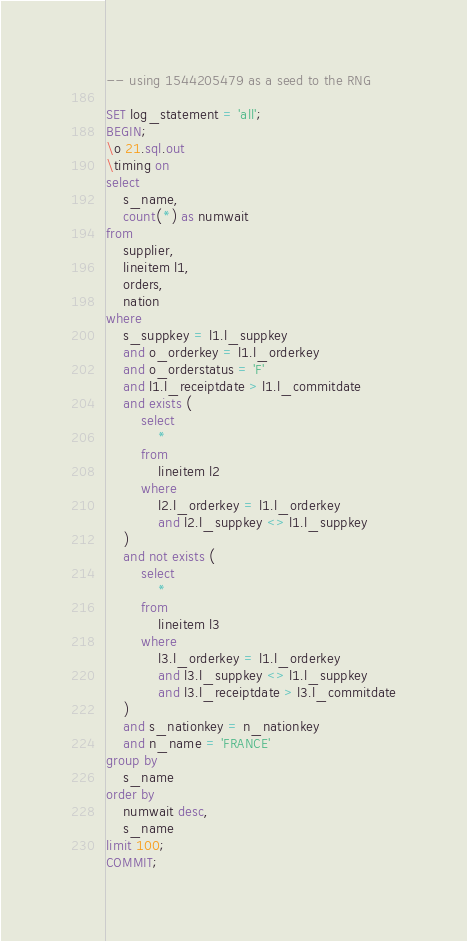<code> <loc_0><loc_0><loc_500><loc_500><_SQL_>-- using 1544205479 as a seed to the RNG

SET log_statement = 'all';
BEGIN;
\o 21.sql.out
\timing on
select
	s_name,
	count(*) as numwait
from
	supplier,
	lineitem l1,
	orders,
	nation
where
	s_suppkey = l1.l_suppkey
	and o_orderkey = l1.l_orderkey
	and o_orderstatus = 'F'
	and l1.l_receiptdate > l1.l_commitdate
	and exists (
		select
			*
		from
			lineitem l2
		where
			l2.l_orderkey = l1.l_orderkey
			and l2.l_suppkey <> l1.l_suppkey
	)
	and not exists (
		select
			*
		from
			lineitem l3
		where
			l3.l_orderkey = l1.l_orderkey
			and l3.l_suppkey <> l1.l_suppkey
			and l3.l_receiptdate > l3.l_commitdate
	)
	and s_nationkey = n_nationkey
	and n_name = 'FRANCE'
group by
	s_name
order by
	numwait desc,
	s_name
limit 100;
COMMIT;
</code> 